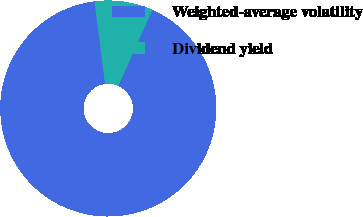<chart> <loc_0><loc_0><loc_500><loc_500><pie_chart><fcel>Weighted-average volatility<fcel>Dividend yield<nl><fcel>91.29%<fcel>8.71%<nl></chart> 